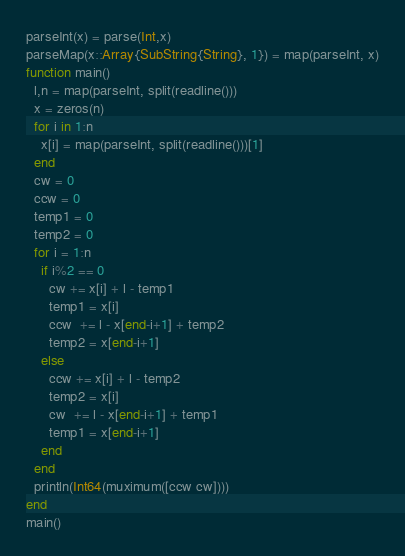Convert code to text. <code><loc_0><loc_0><loc_500><loc_500><_Julia_>parseInt(x) = parse(Int,x)
parseMap(x::Array{SubString{String}, 1}) = map(parseInt, x)
function main()
  l,n = map(parseInt, split(readline()))
  x = zeros(n)
  for i in 1:n
    x[i] = map(parseInt, split(readline()))[1]
  end
  cw = 0
  ccw = 0
  temp1 = 0
  temp2 = 0
  for i = 1:n
    if i%2 == 0
      cw += x[i] + l - temp1
      temp1 = x[i]
      ccw  += l - x[end-i+1] + temp2
      temp2 = x[end-i+1]
    else
      ccw += x[i] + l - temp2
      temp2 = x[i]
      cw  += l - x[end-i+1] + temp1
      temp1 = x[end-i+1]
    end
  end
  println(Int64(muximum([ccw cw])))
end
main()</code> 